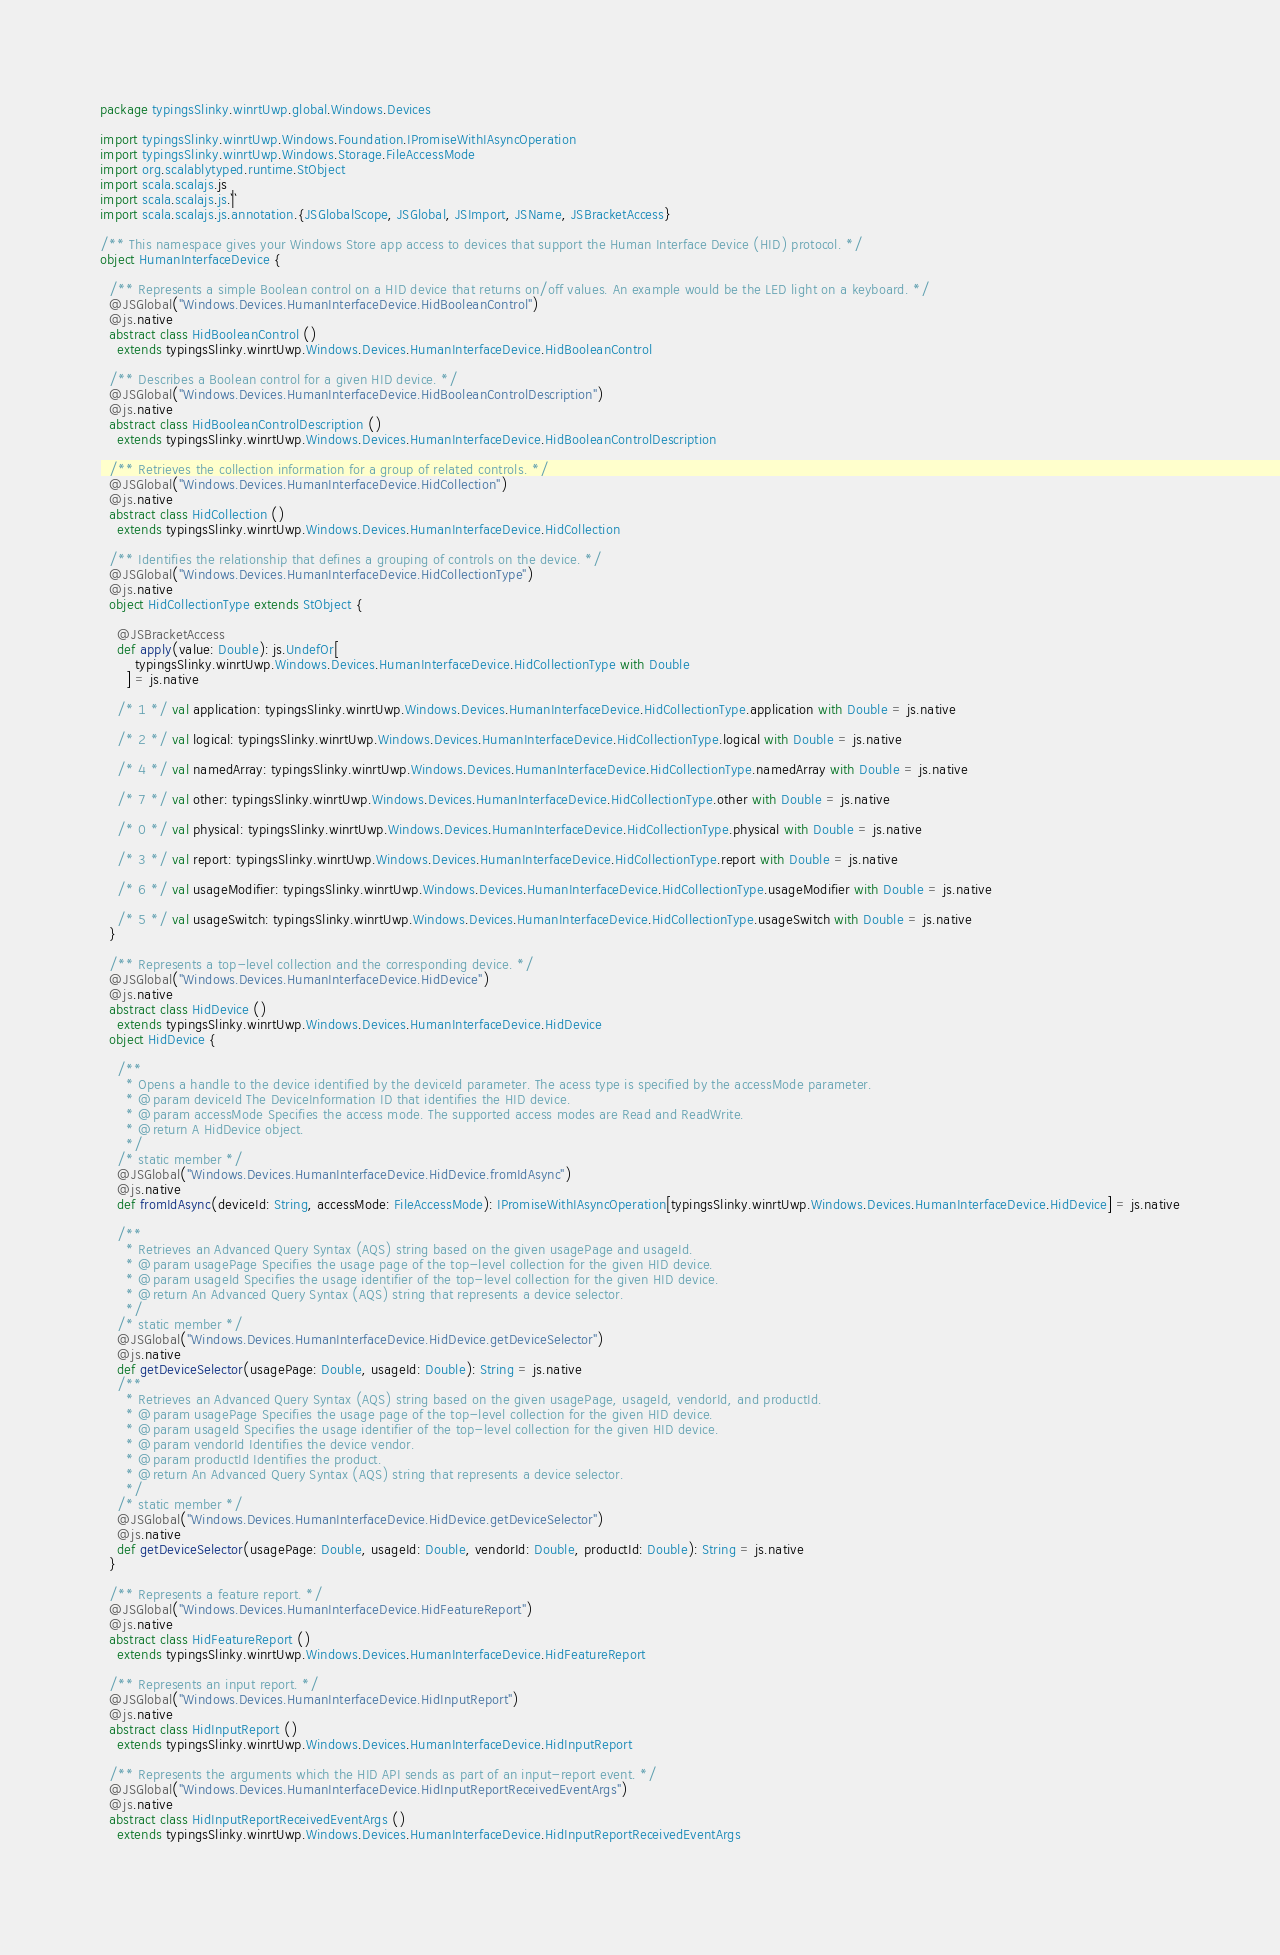<code> <loc_0><loc_0><loc_500><loc_500><_Scala_>package typingsSlinky.winrtUwp.global.Windows.Devices

import typingsSlinky.winrtUwp.Windows.Foundation.IPromiseWithIAsyncOperation
import typingsSlinky.winrtUwp.Windows.Storage.FileAccessMode
import org.scalablytyped.runtime.StObject
import scala.scalajs.js
import scala.scalajs.js.`|`
import scala.scalajs.js.annotation.{JSGlobalScope, JSGlobal, JSImport, JSName, JSBracketAccess}

/** This namespace gives your Windows Store app access to devices that support the Human Interface Device (HID) protocol. */
object HumanInterfaceDevice {
  
  /** Represents a simple Boolean control on a HID device that returns on/off values. An example would be the LED light on a keyboard. */
  @JSGlobal("Windows.Devices.HumanInterfaceDevice.HidBooleanControl")
  @js.native
  abstract class HidBooleanControl ()
    extends typingsSlinky.winrtUwp.Windows.Devices.HumanInterfaceDevice.HidBooleanControl
  
  /** Describes a Boolean control for a given HID device. */
  @JSGlobal("Windows.Devices.HumanInterfaceDevice.HidBooleanControlDescription")
  @js.native
  abstract class HidBooleanControlDescription ()
    extends typingsSlinky.winrtUwp.Windows.Devices.HumanInterfaceDevice.HidBooleanControlDescription
  
  /** Retrieves the collection information for a group of related controls. */
  @JSGlobal("Windows.Devices.HumanInterfaceDevice.HidCollection")
  @js.native
  abstract class HidCollection ()
    extends typingsSlinky.winrtUwp.Windows.Devices.HumanInterfaceDevice.HidCollection
  
  /** Identifies the relationship that defines a grouping of controls on the device. */
  @JSGlobal("Windows.Devices.HumanInterfaceDevice.HidCollectionType")
  @js.native
  object HidCollectionType extends StObject {
    
    @JSBracketAccess
    def apply(value: Double): js.UndefOr[
        typingsSlinky.winrtUwp.Windows.Devices.HumanInterfaceDevice.HidCollectionType with Double
      ] = js.native
    
    /* 1 */ val application: typingsSlinky.winrtUwp.Windows.Devices.HumanInterfaceDevice.HidCollectionType.application with Double = js.native
    
    /* 2 */ val logical: typingsSlinky.winrtUwp.Windows.Devices.HumanInterfaceDevice.HidCollectionType.logical with Double = js.native
    
    /* 4 */ val namedArray: typingsSlinky.winrtUwp.Windows.Devices.HumanInterfaceDevice.HidCollectionType.namedArray with Double = js.native
    
    /* 7 */ val other: typingsSlinky.winrtUwp.Windows.Devices.HumanInterfaceDevice.HidCollectionType.other with Double = js.native
    
    /* 0 */ val physical: typingsSlinky.winrtUwp.Windows.Devices.HumanInterfaceDevice.HidCollectionType.physical with Double = js.native
    
    /* 3 */ val report: typingsSlinky.winrtUwp.Windows.Devices.HumanInterfaceDevice.HidCollectionType.report with Double = js.native
    
    /* 6 */ val usageModifier: typingsSlinky.winrtUwp.Windows.Devices.HumanInterfaceDevice.HidCollectionType.usageModifier with Double = js.native
    
    /* 5 */ val usageSwitch: typingsSlinky.winrtUwp.Windows.Devices.HumanInterfaceDevice.HidCollectionType.usageSwitch with Double = js.native
  }
  
  /** Represents a top-level collection and the corresponding device. */
  @JSGlobal("Windows.Devices.HumanInterfaceDevice.HidDevice")
  @js.native
  abstract class HidDevice ()
    extends typingsSlinky.winrtUwp.Windows.Devices.HumanInterfaceDevice.HidDevice
  object HidDevice {
    
    /**
      * Opens a handle to the device identified by the deviceId parameter. The acess type is specified by the accessMode parameter.
      * @param deviceId The DeviceInformation ID that identifies the HID device.
      * @param accessMode Specifies the access mode. The supported access modes are Read and ReadWrite.
      * @return A HidDevice object.
      */
    /* static member */
    @JSGlobal("Windows.Devices.HumanInterfaceDevice.HidDevice.fromIdAsync")
    @js.native
    def fromIdAsync(deviceId: String, accessMode: FileAccessMode): IPromiseWithIAsyncOperation[typingsSlinky.winrtUwp.Windows.Devices.HumanInterfaceDevice.HidDevice] = js.native
    
    /**
      * Retrieves an Advanced Query Syntax (AQS) string based on the given usagePage and usageId.
      * @param usagePage Specifies the usage page of the top-level collection for the given HID device.
      * @param usageId Specifies the usage identifier of the top-level collection for the given HID device.
      * @return An Advanced Query Syntax (AQS) string that represents a device selector.
      */
    /* static member */
    @JSGlobal("Windows.Devices.HumanInterfaceDevice.HidDevice.getDeviceSelector")
    @js.native
    def getDeviceSelector(usagePage: Double, usageId: Double): String = js.native
    /**
      * Retrieves an Advanced Query Syntax (AQS) string based on the given usagePage, usageId, vendorId, and productId.
      * @param usagePage Specifies the usage page of the top-level collection for the given HID device.
      * @param usageId Specifies the usage identifier of the top-level collection for the given HID device.
      * @param vendorId Identifies the device vendor.
      * @param productId Identifies the product.
      * @return An Advanced Query Syntax (AQS) string that represents a device selector.
      */
    /* static member */
    @JSGlobal("Windows.Devices.HumanInterfaceDevice.HidDevice.getDeviceSelector")
    @js.native
    def getDeviceSelector(usagePage: Double, usageId: Double, vendorId: Double, productId: Double): String = js.native
  }
  
  /** Represents a feature report. */
  @JSGlobal("Windows.Devices.HumanInterfaceDevice.HidFeatureReport")
  @js.native
  abstract class HidFeatureReport ()
    extends typingsSlinky.winrtUwp.Windows.Devices.HumanInterfaceDevice.HidFeatureReport
  
  /** Represents an input report. */
  @JSGlobal("Windows.Devices.HumanInterfaceDevice.HidInputReport")
  @js.native
  abstract class HidInputReport ()
    extends typingsSlinky.winrtUwp.Windows.Devices.HumanInterfaceDevice.HidInputReport
  
  /** Represents the arguments which the HID API sends as part of an input-report event. */
  @JSGlobal("Windows.Devices.HumanInterfaceDevice.HidInputReportReceivedEventArgs")
  @js.native
  abstract class HidInputReportReceivedEventArgs ()
    extends typingsSlinky.winrtUwp.Windows.Devices.HumanInterfaceDevice.HidInputReportReceivedEventArgs
  </code> 